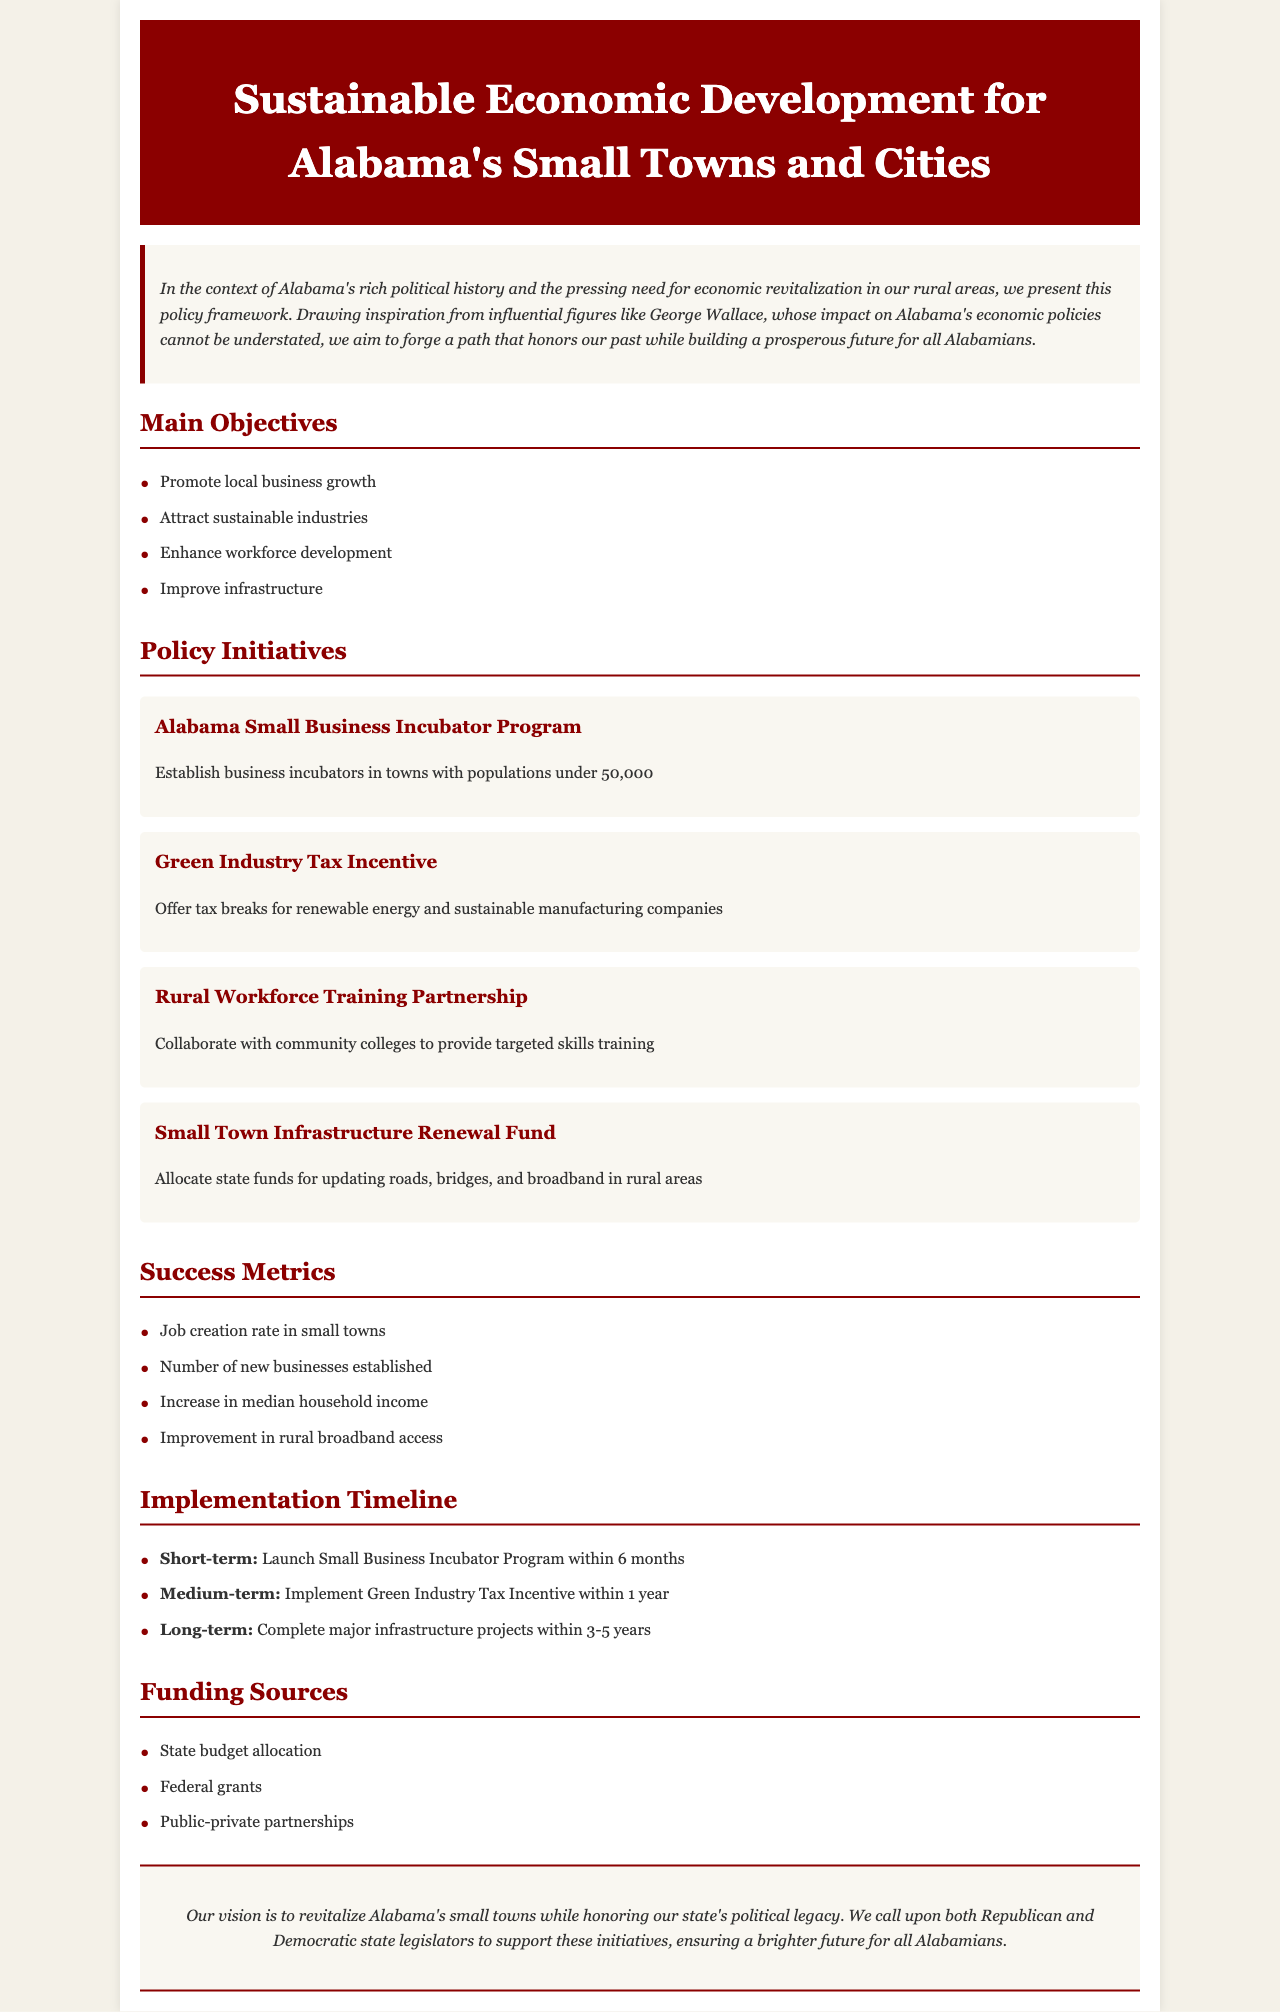What are the main objectives of the policy? The main objectives are listed under the "Main Objectives" section of the document: Promote local business growth, Attract sustainable industries, Enhance workforce development, Improve infrastructure.
Answer: Promote local business growth, Attract sustainable industries, Enhance workforce development, Improve infrastructure What initiative focuses on business incubators? The initiative that focuses on business incubators is described in the "Policy Initiatives" section.
Answer: Alabama Small Business Incubator Program What is the short-term goal of the implementation timeline? The short-term goal is specified in the "Implementation Timeline" section, stating what should be launched within the next six months.
Answer: Launch Small Business Incubator Program within 6 months Which funding source is mentioned for the initiatives? The funding sources are listed in the "Funding Sources" section of the document.
Answer: State budget allocation What is the target demographic for the Rural Workforce Training Partnership? The target demographic of this initiative is found in the description of the initiative under "Policy Initiatives."
Answer: Community colleges What improvement is expected from the metrics section? The improvement metrics are listed in the "Success Metrics" section and specify what should increase as a result of the initiatives.
Answer: Increase in median household income How long is the medium-term implementation expected to take? The medium-term implementation is described with a specific time frame in the "Implementation Timeline" section.
Answer: 1 year What is the overarching vision stated in the conclusion? The conclusion summarizes the vision of the document, which can be found at the end.
Answer: Revitalize Alabama's small towns while honoring our state's political legacy 